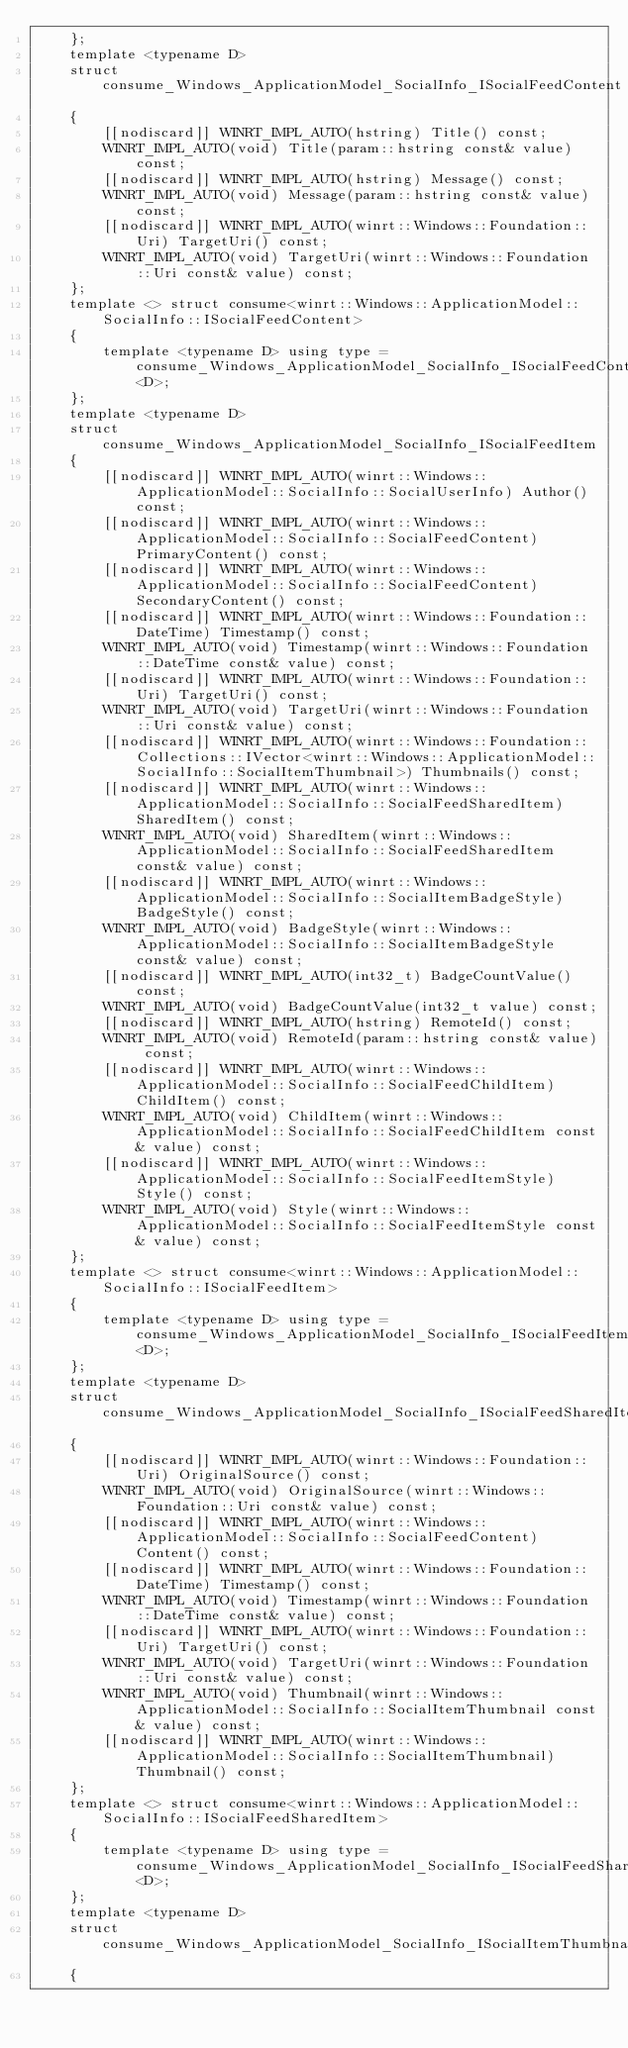Convert code to text. <code><loc_0><loc_0><loc_500><loc_500><_C_>    };
    template <typename D>
    struct consume_Windows_ApplicationModel_SocialInfo_ISocialFeedContent
    {
        [[nodiscard]] WINRT_IMPL_AUTO(hstring) Title() const;
        WINRT_IMPL_AUTO(void) Title(param::hstring const& value) const;
        [[nodiscard]] WINRT_IMPL_AUTO(hstring) Message() const;
        WINRT_IMPL_AUTO(void) Message(param::hstring const& value) const;
        [[nodiscard]] WINRT_IMPL_AUTO(winrt::Windows::Foundation::Uri) TargetUri() const;
        WINRT_IMPL_AUTO(void) TargetUri(winrt::Windows::Foundation::Uri const& value) const;
    };
    template <> struct consume<winrt::Windows::ApplicationModel::SocialInfo::ISocialFeedContent>
    {
        template <typename D> using type = consume_Windows_ApplicationModel_SocialInfo_ISocialFeedContent<D>;
    };
    template <typename D>
    struct consume_Windows_ApplicationModel_SocialInfo_ISocialFeedItem
    {
        [[nodiscard]] WINRT_IMPL_AUTO(winrt::Windows::ApplicationModel::SocialInfo::SocialUserInfo) Author() const;
        [[nodiscard]] WINRT_IMPL_AUTO(winrt::Windows::ApplicationModel::SocialInfo::SocialFeedContent) PrimaryContent() const;
        [[nodiscard]] WINRT_IMPL_AUTO(winrt::Windows::ApplicationModel::SocialInfo::SocialFeedContent) SecondaryContent() const;
        [[nodiscard]] WINRT_IMPL_AUTO(winrt::Windows::Foundation::DateTime) Timestamp() const;
        WINRT_IMPL_AUTO(void) Timestamp(winrt::Windows::Foundation::DateTime const& value) const;
        [[nodiscard]] WINRT_IMPL_AUTO(winrt::Windows::Foundation::Uri) TargetUri() const;
        WINRT_IMPL_AUTO(void) TargetUri(winrt::Windows::Foundation::Uri const& value) const;
        [[nodiscard]] WINRT_IMPL_AUTO(winrt::Windows::Foundation::Collections::IVector<winrt::Windows::ApplicationModel::SocialInfo::SocialItemThumbnail>) Thumbnails() const;
        [[nodiscard]] WINRT_IMPL_AUTO(winrt::Windows::ApplicationModel::SocialInfo::SocialFeedSharedItem) SharedItem() const;
        WINRT_IMPL_AUTO(void) SharedItem(winrt::Windows::ApplicationModel::SocialInfo::SocialFeedSharedItem const& value) const;
        [[nodiscard]] WINRT_IMPL_AUTO(winrt::Windows::ApplicationModel::SocialInfo::SocialItemBadgeStyle) BadgeStyle() const;
        WINRT_IMPL_AUTO(void) BadgeStyle(winrt::Windows::ApplicationModel::SocialInfo::SocialItemBadgeStyle const& value) const;
        [[nodiscard]] WINRT_IMPL_AUTO(int32_t) BadgeCountValue() const;
        WINRT_IMPL_AUTO(void) BadgeCountValue(int32_t value) const;
        [[nodiscard]] WINRT_IMPL_AUTO(hstring) RemoteId() const;
        WINRT_IMPL_AUTO(void) RemoteId(param::hstring const& value) const;
        [[nodiscard]] WINRT_IMPL_AUTO(winrt::Windows::ApplicationModel::SocialInfo::SocialFeedChildItem) ChildItem() const;
        WINRT_IMPL_AUTO(void) ChildItem(winrt::Windows::ApplicationModel::SocialInfo::SocialFeedChildItem const& value) const;
        [[nodiscard]] WINRT_IMPL_AUTO(winrt::Windows::ApplicationModel::SocialInfo::SocialFeedItemStyle) Style() const;
        WINRT_IMPL_AUTO(void) Style(winrt::Windows::ApplicationModel::SocialInfo::SocialFeedItemStyle const& value) const;
    };
    template <> struct consume<winrt::Windows::ApplicationModel::SocialInfo::ISocialFeedItem>
    {
        template <typename D> using type = consume_Windows_ApplicationModel_SocialInfo_ISocialFeedItem<D>;
    };
    template <typename D>
    struct consume_Windows_ApplicationModel_SocialInfo_ISocialFeedSharedItem
    {
        [[nodiscard]] WINRT_IMPL_AUTO(winrt::Windows::Foundation::Uri) OriginalSource() const;
        WINRT_IMPL_AUTO(void) OriginalSource(winrt::Windows::Foundation::Uri const& value) const;
        [[nodiscard]] WINRT_IMPL_AUTO(winrt::Windows::ApplicationModel::SocialInfo::SocialFeedContent) Content() const;
        [[nodiscard]] WINRT_IMPL_AUTO(winrt::Windows::Foundation::DateTime) Timestamp() const;
        WINRT_IMPL_AUTO(void) Timestamp(winrt::Windows::Foundation::DateTime const& value) const;
        [[nodiscard]] WINRT_IMPL_AUTO(winrt::Windows::Foundation::Uri) TargetUri() const;
        WINRT_IMPL_AUTO(void) TargetUri(winrt::Windows::Foundation::Uri const& value) const;
        WINRT_IMPL_AUTO(void) Thumbnail(winrt::Windows::ApplicationModel::SocialInfo::SocialItemThumbnail const& value) const;
        [[nodiscard]] WINRT_IMPL_AUTO(winrt::Windows::ApplicationModel::SocialInfo::SocialItemThumbnail) Thumbnail() const;
    };
    template <> struct consume<winrt::Windows::ApplicationModel::SocialInfo::ISocialFeedSharedItem>
    {
        template <typename D> using type = consume_Windows_ApplicationModel_SocialInfo_ISocialFeedSharedItem<D>;
    };
    template <typename D>
    struct consume_Windows_ApplicationModel_SocialInfo_ISocialItemThumbnail
    {</code> 